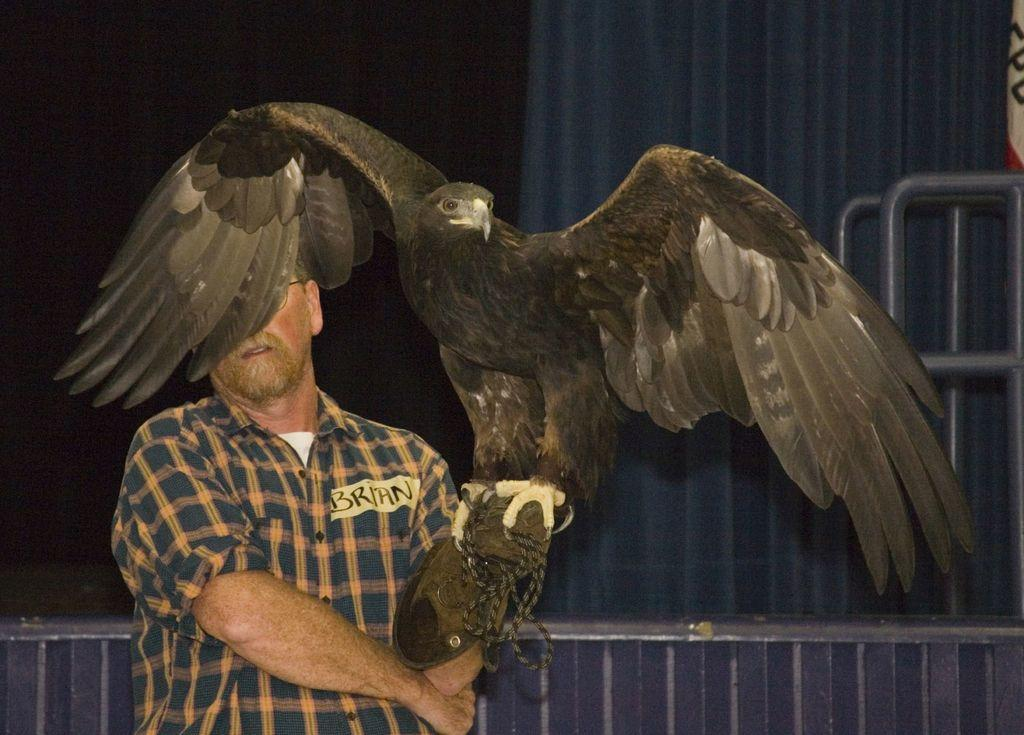What type of bird is in the image? There is an eagle in the image. What is the color of the eagle? The eagle is black in color. Where is the man in the image located? The man is on the left side of the image. What is the man wearing? The man is wearing gloves. What can be seen in the background of the image? There is a railing and a shed in the background of the image. How does the snail end its journey in the image? There is no snail present in the image, so it cannot end its journey. 